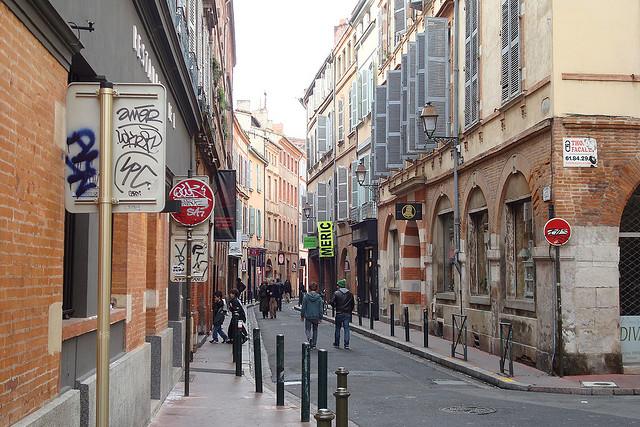Are the signs English?
Quick response, please. No. How many lights on the building?
Be succinct. 2. Are there cars on the street?
Quick response, please. No. Is this Chinatown?
Quick response, please. No. What color is the building?
Give a very brief answer. Brown. What city is this taken in?
Quick response, please. Berlin. 